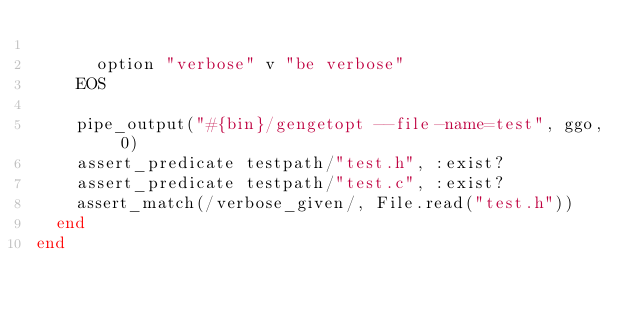<code> <loc_0><loc_0><loc_500><loc_500><_Ruby_>
      option "verbose" v "be verbose"
    EOS

    pipe_output("#{bin}/gengetopt --file-name=test", ggo, 0)
    assert_predicate testpath/"test.h", :exist?
    assert_predicate testpath/"test.c", :exist?
    assert_match(/verbose_given/, File.read("test.h"))
  end
end
</code> 